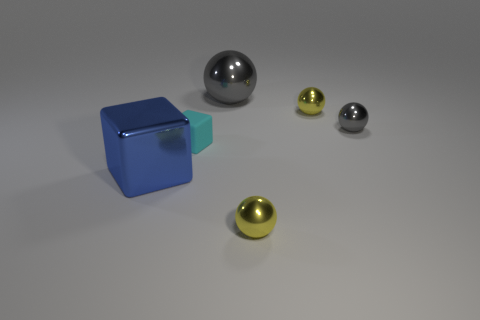Are there any other things that have the same material as the tiny cyan thing?
Your answer should be very brief. No. There is a big object in front of the gray ball that is behind the gray metallic sphere right of the big metal ball; what is its material?
Offer a very short reply. Metal. What material is the object that is the same color as the big sphere?
Your answer should be compact. Metal. How many objects are either big blue things or yellow metal things?
Your response must be concise. 3. Do the tiny object in front of the cyan rubber object and the large sphere have the same material?
Offer a terse response. Yes. How many things are either tiny balls that are in front of the small cyan rubber block or small yellow shiny cubes?
Provide a succinct answer. 1. What color is the large cube that is made of the same material as the tiny gray sphere?
Your answer should be very brief. Blue. Are there any yellow things that have the same size as the cyan matte thing?
Make the answer very short. Yes. There is a big thing that is right of the large blue metal thing; is it the same color as the matte block?
Your response must be concise. No. What is the color of the object that is both to the left of the big gray thing and behind the blue metallic object?
Give a very brief answer. Cyan. 